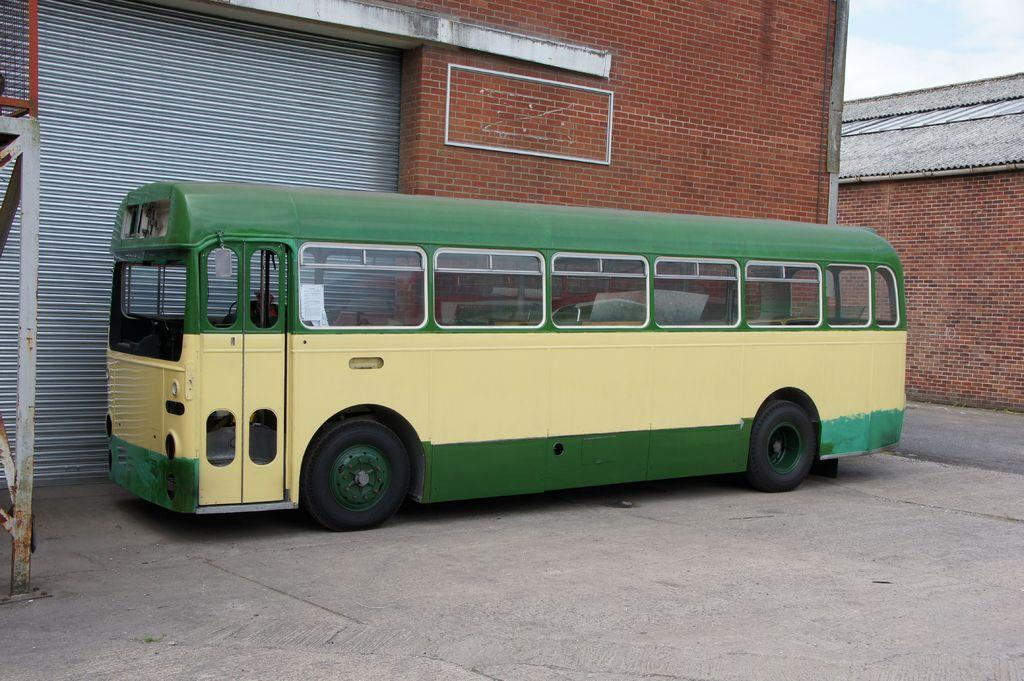What is the main subject of the image? The main subject of the image is a bus. Can you describe the color of the bus? The bus is pale yellow and green in color. What feature of the bus can be seen in the image? The bus has windows. What is the setting of the image? The image features a road, a brick wall, and a shutter. How would you describe the weather in the image? The sky is cloudy in the image. Can you see any signs of loss or quivering in the image? There is no indication of loss or quivering in the image; it primarily features a bus and its surroundings. 